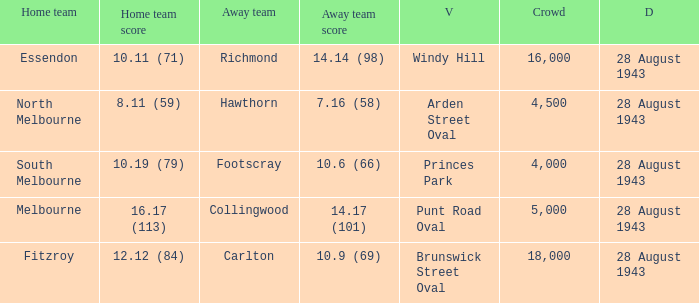Where was the game played with an away team score of 14.17 (101)? Punt Road Oval. 